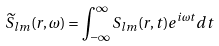<formula> <loc_0><loc_0><loc_500><loc_500>\widetilde { S } _ { l m } ( r , \omega ) = \int _ { - \infty } ^ { \infty } S _ { l m } ( r , t ) e ^ { i \omega t } d t</formula> 